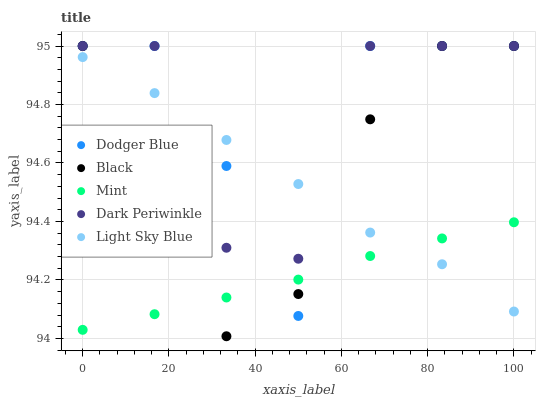Does Mint have the minimum area under the curve?
Answer yes or no. Yes. Does Dodger Blue have the maximum area under the curve?
Answer yes or no. Yes. Does Light Sky Blue have the minimum area under the curve?
Answer yes or no. No. Does Light Sky Blue have the maximum area under the curve?
Answer yes or no. No. Is Mint the smoothest?
Answer yes or no. Yes. Is Dodger Blue the roughest?
Answer yes or no. Yes. Is Light Sky Blue the smoothest?
Answer yes or no. No. Is Light Sky Blue the roughest?
Answer yes or no. No. Does Black have the lowest value?
Answer yes or no. Yes. Does Light Sky Blue have the lowest value?
Answer yes or no. No. Does Dark Periwinkle have the highest value?
Answer yes or no. Yes. Does Light Sky Blue have the highest value?
Answer yes or no. No. Is Mint less than Dark Periwinkle?
Answer yes or no. Yes. Is Dark Periwinkle greater than Mint?
Answer yes or no. Yes. Does Black intersect Dodger Blue?
Answer yes or no. Yes. Is Black less than Dodger Blue?
Answer yes or no. No. Is Black greater than Dodger Blue?
Answer yes or no. No. Does Mint intersect Dark Periwinkle?
Answer yes or no. No. 